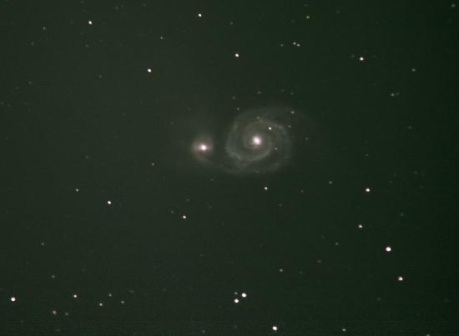What are the key elements in this picture? The image captures the stunning complexity of the cosmos with a spiral galaxy as the focal point. This galaxy, resplendent with its bright core, is interwoven with delicate spiral arms that twirl into the depths of space. Amidst the cosmic dance of the galaxy, a scattering of stars contribute to this astronomical panorama, their sizes ranging from mere pinpricks of light to more noticeable celestial bodies. The void of space provides a stark, dark backdrop, amplifying the galaxy and the stars' radiant presence. This celestial ensemble invites contemplation of the universe's grandeur and the mystery of the vast, starry expanse beyond our own world. 